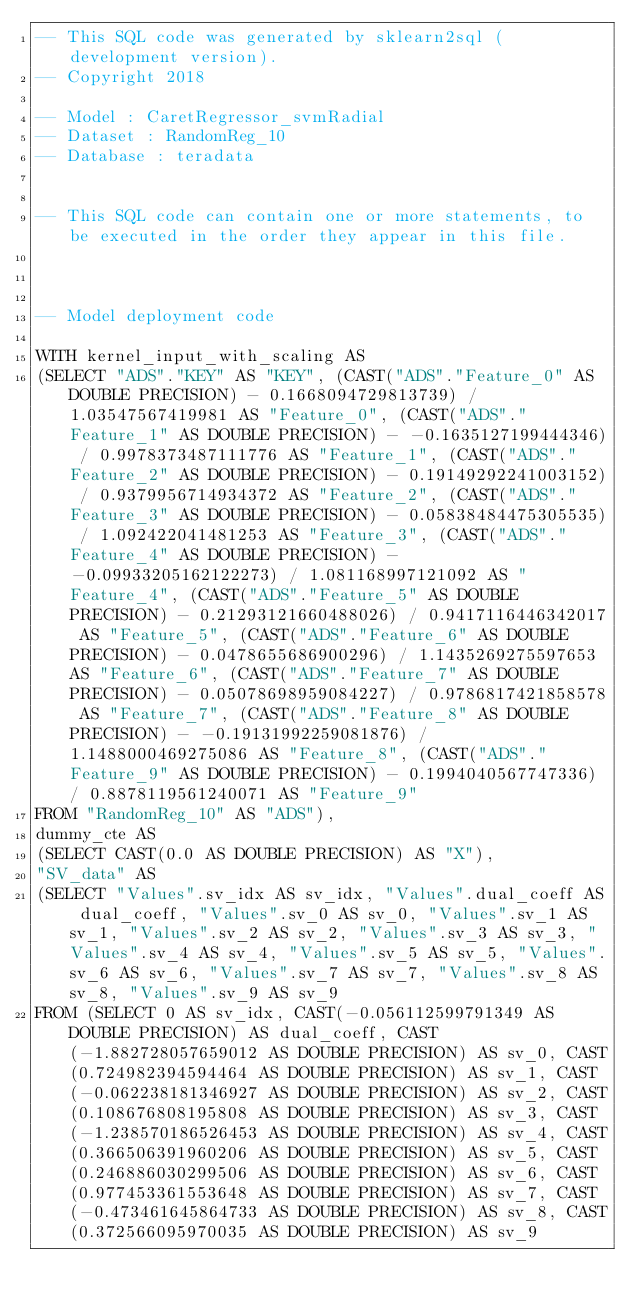<code> <loc_0><loc_0><loc_500><loc_500><_SQL_>-- This SQL code was generated by sklearn2sql (development version).
-- Copyright 2018

-- Model : CaretRegressor_svmRadial
-- Dataset : RandomReg_10
-- Database : teradata


-- This SQL code can contain one or more statements, to be executed in the order they appear in this file.



-- Model deployment code

WITH kernel_input_with_scaling AS 
(SELECT "ADS"."KEY" AS "KEY", (CAST("ADS"."Feature_0" AS DOUBLE PRECISION) - 0.1668094729813739) / 1.03547567419981 AS "Feature_0", (CAST("ADS"."Feature_1" AS DOUBLE PRECISION) - -0.1635127199444346) / 0.9978373487111776 AS "Feature_1", (CAST("ADS"."Feature_2" AS DOUBLE PRECISION) - 0.19149292241003152) / 0.9379956714934372 AS "Feature_2", (CAST("ADS"."Feature_3" AS DOUBLE PRECISION) - 0.05838484475305535) / 1.092422041481253 AS "Feature_3", (CAST("ADS"."Feature_4" AS DOUBLE PRECISION) - -0.09933205162122273) / 1.081168997121092 AS "Feature_4", (CAST("ADS"."Feature_5" AS DOUBLE PRECISION) - 0.21293121660488026) / 0.9417116446342017 AS "Feature_5", (CAST("ADS"."Feature_6" AS DOUBLE PRECISION) - 0.0478655686900296) / 1.1435269275597653 AS "Feature_6", (CAST("ADS"."Feature_7" AS DOUBLE PRECISION) - 0.05078698959084227) / 0.9786817421858578 AS "Feature_7", (CAST("ADS"."Feature_8" AS DOUBLE PRECISION) - -0.19131992259081876) / 1.1488000469275086 AS "Feature_8", (CAST("ADS"."Feature_9" AS DOUBLE PRECISION) - 0.1994040567747336) / 0.8878119561240071 AS "Feature_9" 
FROM "RandomReg_10" AS "ADS"), 
dummy_cte AS 
(SELECT CAST(0.0 AS DOUBLE PRECISION) AS "X"), 
"SV_data" AS 
(SELECT "Values".sv_idx AS sv_idx, "Values".dual_coeff AS dual_coeff, "Values".sv_0 AS sv_0, "Values".sv_1 AS sv_1, "Values".sv_2 AS sv_2, "Values".sv_3 AS sv_3, "Values".sv_4 AS sv_4, "Values".sv_5 AS sv_5, "Values".sv_6 AS sv_6, "Values".sv_7 AS sv_7, "Values".sv_8 AS sv_8, "Values".sv_9 AS sv_9 
FROM (SELECT 0 AS sv_idx, CAST(-0.056112599791349 AS DOUBLE PRECISION) AS dual_coeff, CAST(-1.882728057659012 AS DOUBLE PRECISION) AS sv_0, CAST(0.724982394594464 AS DOUBLE PRECISION) AS sv_1, CAST(-0.062238181346927 AS DOUBLE PRECISION) AS sv_2, CAST(0.108676808195808 AS DOUBLE PRECISION) AS sv_3, CAST(-1.238570186526453 AS DOUBLE PRECISION) AS sv_4, CAST(0.366506391960206 AS DOUBLE PRECISION) AS sv_5, CAST(0.246886030299506 AS DOUBLE PRECISION) AS sv_6, CAST(0.977453361553648 AS DOUBLE PRECISION) AS sv_7, CAST(-0.473461645864733 AS DOUBLE PRECISION) AS sv_8, CAST(0.372566095970035 AS DOUBLE PRECISION) AS sv_9 </code> 